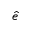Convert formula to latex. <formula><loc_0><loc_0><loc_500><loc_500>\hat { e }</formula> 